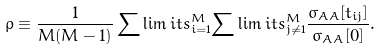Convert formula to latex. <formula><loc_0><loc_0><loc_500><loc_500>\rho \equiv \frac { 1 } { M ( M - 1 ) } \sum \lim i t s _ { i = 1 } ^ { M } { \sum \lim i t s _ { j \ne 1 } ^ { M } { \frac { { \sigma _ { A A } [ t _ { i j } ] } } { { \sigma _ { A A } [ 0 ] } } . } }</formula> 